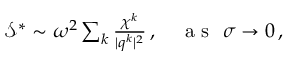Convert formula to latex. <formula><loc_0><loc_0><loc_500><loc_500>\begin{array} { r } { \mathcal { S } ^ { * } \sim \omega ^ { 2 } \sum _ { k } \frac { \chi ^ { k } } { | q ^ { k } | ^ { 2 } } \, , a s \sigma \rightarrow 0 \, , } \end{array}</formula> 